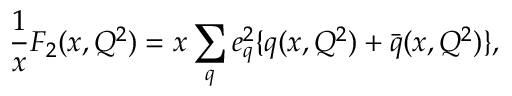Convert formula to latex. <formula><loc_0><loc_0><loc_500><loc_500>\frac { 1 } { x } F _ { 2 } ( x , Q ^ { 2 } ) = x \sum _ { q } e _ { q } ^ { 2 } \{ q ( x , Q ^ { 2 } ) + \bar { q } ( x , Q ^ { 2 } ) \} ,</formula> 